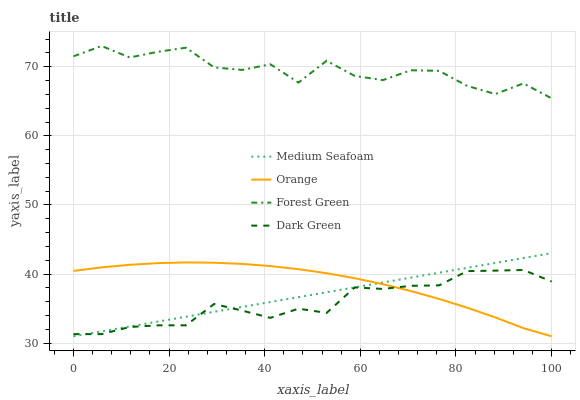Does Dark Green have the minimum area under the curve?
Answer yes or no. Yes. Does Forest Green have the maximum area under the curve?
Answer yes or no. Yes. Does Medium Seafoam have the minimum area under the curve?
Answer yes or no. No. Does Medium Seafoam have the maximum area under the curve?
Answer yes or no. No. Is Medium Seafoam the smoothest?
Answer yes or no. Yes. Is Forest Green the roughest?
Answer yes or no. Yes. Is Forest Green the smoothest?
Answer yes or no. No. Is Medium Seafoam the roughest?
Answer yes or no. No. Does Orange have the lowest value?
Answer yes or no. Yes. Does Forest Green have the lowest value?
Answer yes or no. No. Does Forest Green have the highest value?
Answer yes or no. Yes. Does Medium Seafoam have the highest value?
Answer yes or no. No. Is Dark Green less than Forest Green?
Answer yes or no. Yes. Is Forest Green greater than Medium Seafoam?
Answer yes or no. Yes. Does Medium Seafoam intersect Dark Green?
Answer yes or no. Yes. Is Medium Seafoam less than Dark Green?
Answer yes or no. No. Is Medium Seafoam greater than Dark Green?
Answer yes or no. No. Does Dark Green intersect Forest Green?
Answer yes or no. No. 